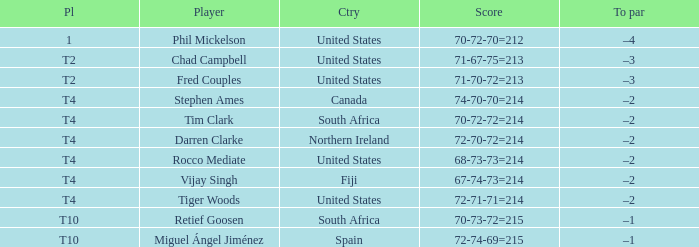What is Rocco Mediate's par? –2. 